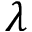<formula> <loc_0><loc_0><loc_500><loc_500>\lambda</formula> 